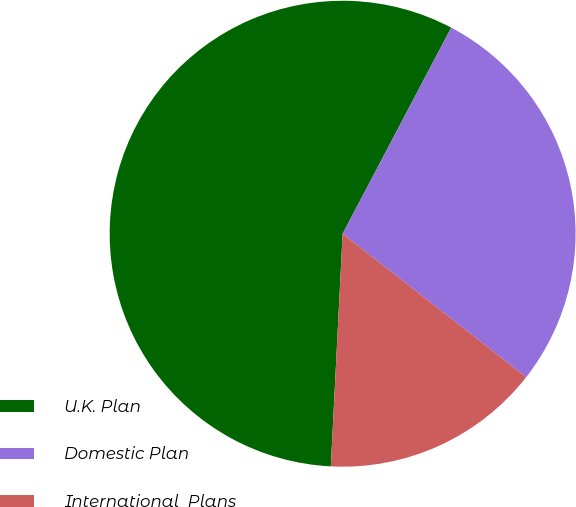Convert chart to OTSL. <chart><loc_0><loc_0><loc_500><loc_500><pie_chart><fcel>U.K. Plan<fcel>Domestic Plan<fcel>International  Plans<nl><fcel>56.91%<fcel>27.84%<fcel>15.25%<nl></chart> 